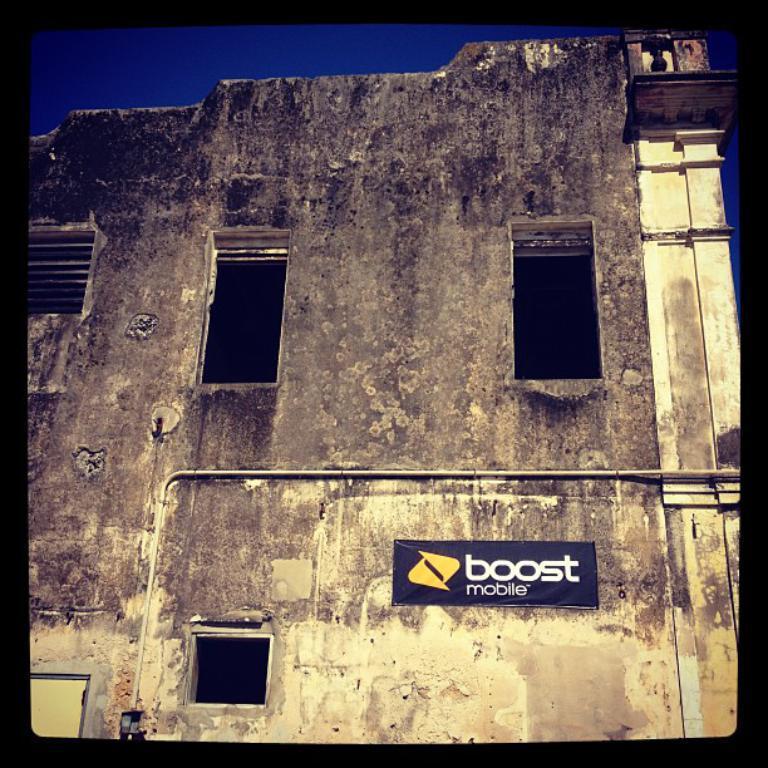How would you summarize this image in a sentence or two? In this image we can see a building, board, and sky. 